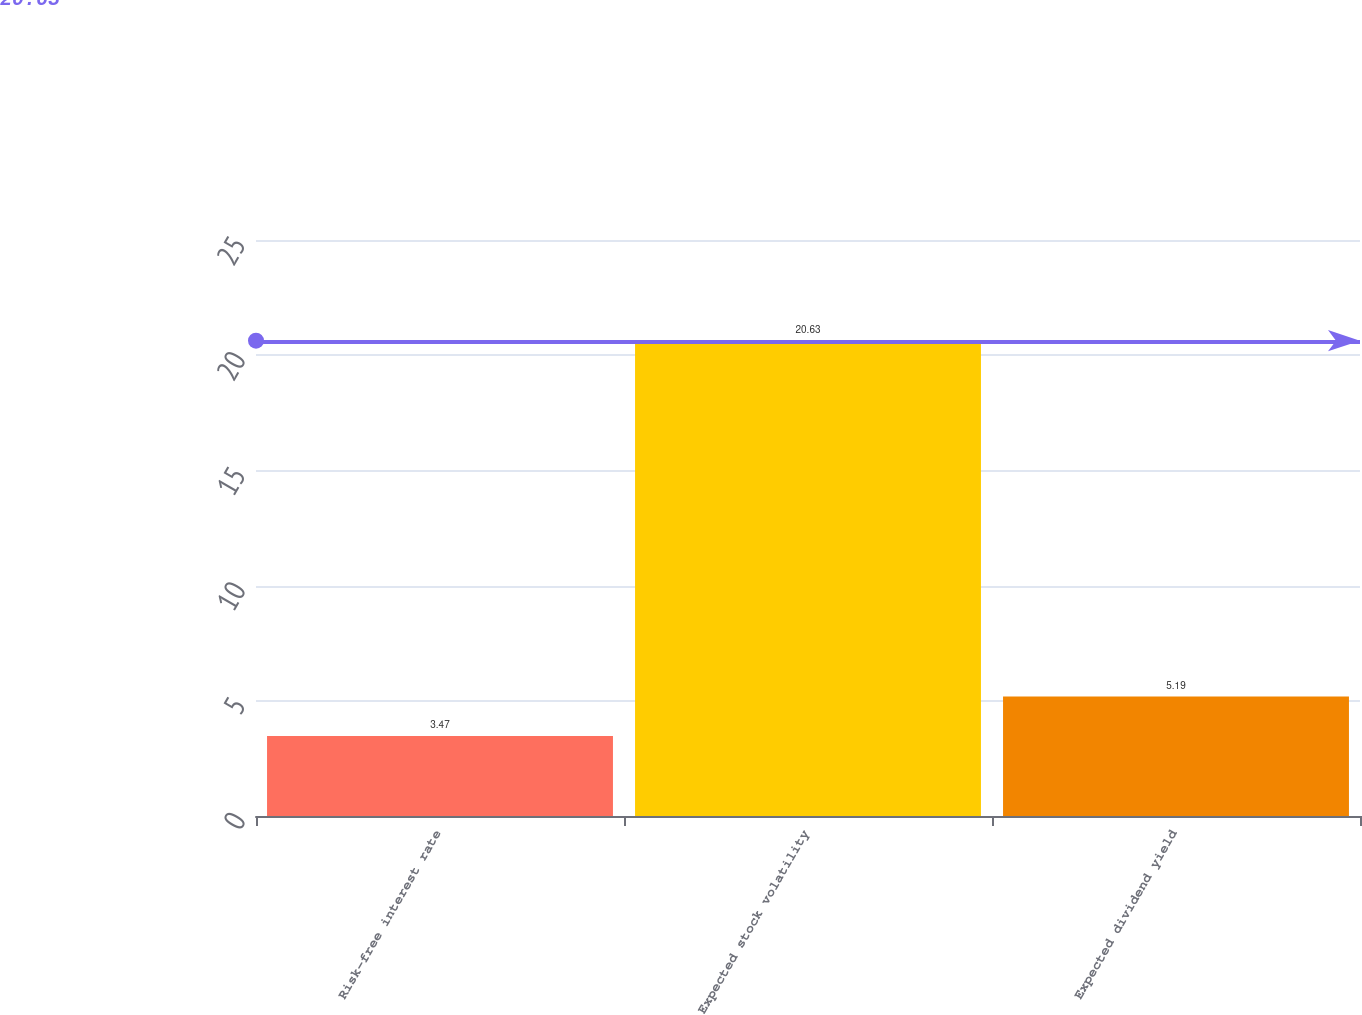<chart> <loc_0><loc_0><loc_500><loc_500><bar_chart><fcel>Risk-free interest rate<fcel>Expected stock volatility<fcel>Expected dividend yield<nl><fcel>3.47<fcel>20.63<fcel>5.19<nl></chart> 